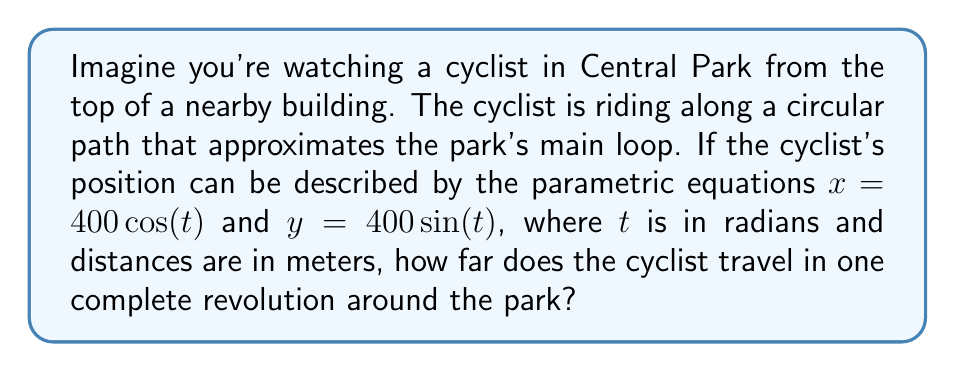What is the answer to this math problem? To solve this problem, we'll follow these steps:

1) First, we need to recognize that these parametric equations describe a circle. The general form of parametric equations for a circle is:

   $x = r \cos(t)$
   $y = r \sin(t)$

   Where $r$ is the radius of the circle.

2) In our case, $r = 400$ meters.

3) To find the distance traveled in one complete revolution, we need to calculate the circumference of this circle.

4) The formula for the circumference of a circle is:

   $C = 2\pi r$

5) Substituting our radius:

   $C = 2\pi(400)$

6) Simplify:

   $C = 800\pi$ meters

7) If we want to express this in kilometers, we can divide by 1000:

   $C = \frac{800\pi}{1000} = 0.8\pi$ kilometers

This result (approximately 2.51 kilometers) is close to the actual length of the main loop in Central Park, which is about 6 miles or 9.7 kilometers for a full circuit, keeping in mind that our model is a simplified circular approximation.
Answer: The cyclist travels $800\pi$ meters (or $0.8\pi$ kilometers) in one complete revolution around the circular path. 